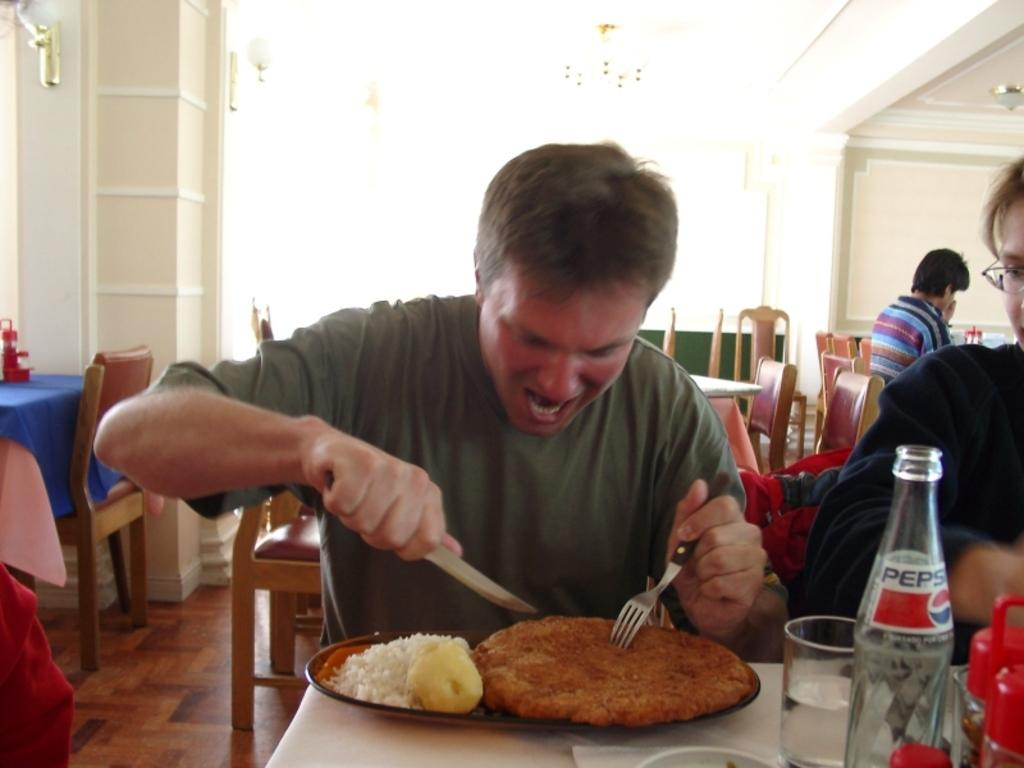<image>
Create a compact narrative representing the image presented. A man digging into a large plate of food with a bottle of Pepsi. 